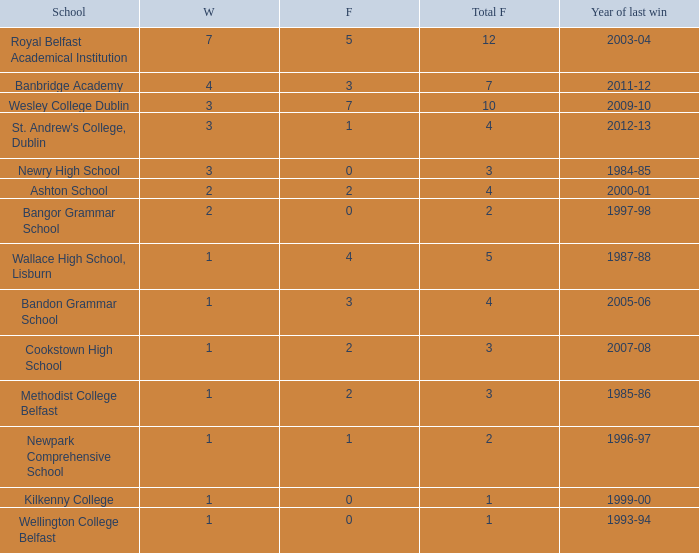What is the name of the school where the year of last win is 1985-86? Methodist College Belfast. 